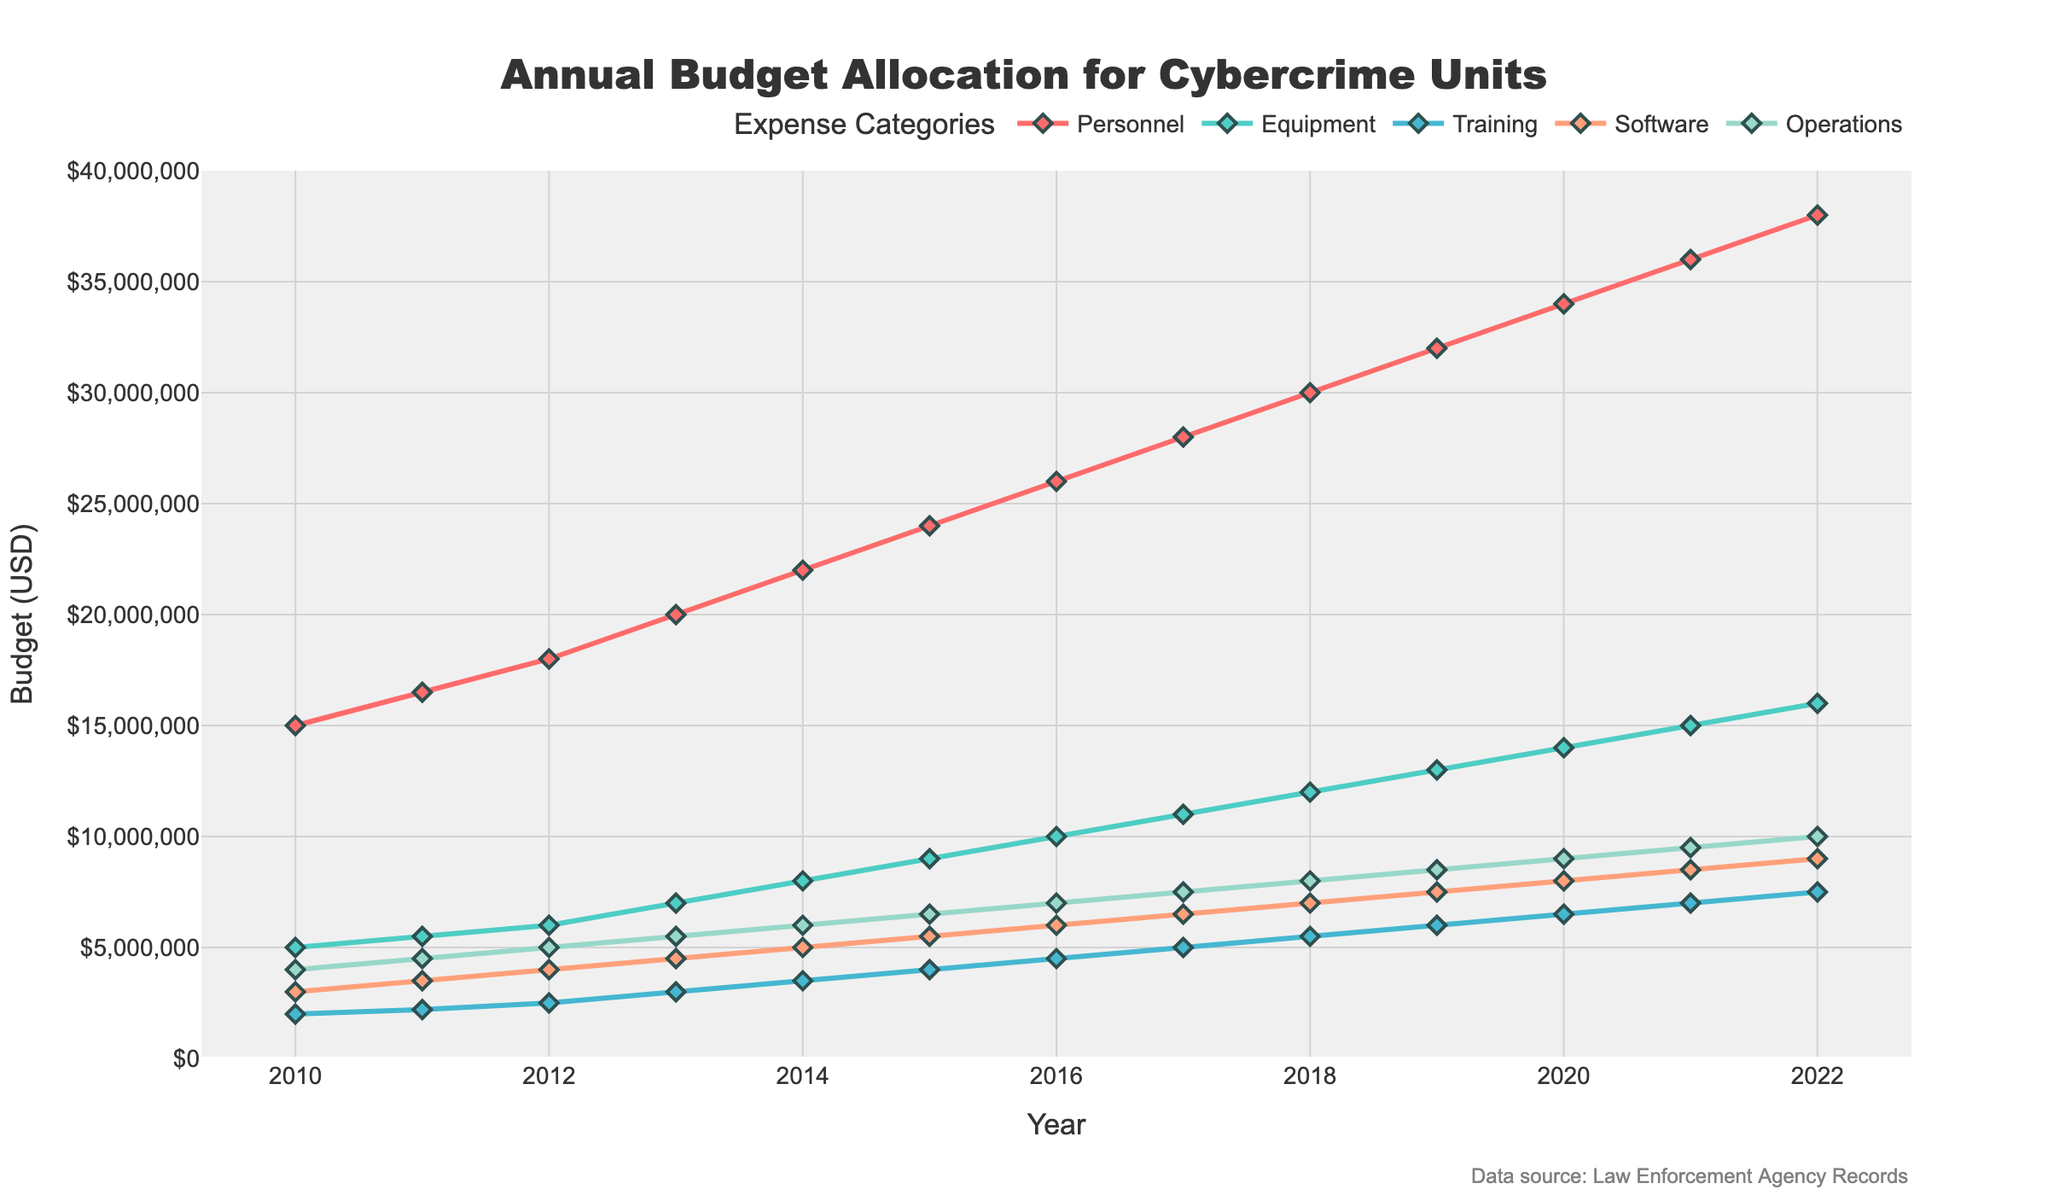What is the budget allocated to Personnel in 2014? Locate the point for the Personnel category on the line chart for the year 2014 and read the corresponding value.
Answer: 22000000 USD Between which years did the Equipment budget see the highest increase, and by how much? Compare the values of Equipment for consecutive years, and find the pair of years with the largest difference. The largest increase is from 2020 to 2021, calculated as 15000000 - 14000000.
Answer: 2020 and 2021, by 1000000 USD Which expense category had the smallest budget allocation in 2012, and what was the amount? Identify the lowest value among Personnel, Equipment, Training, Software, and Operations in 2012. The smallest value is Training with 2500000.
Answer: Training, 2500000 USD What is the total budget allocated to Operations between 2015 and 2017? Add the values for Operations in 2015, 2016, and 2017: 6500000 + 7000000 + 7500000.
Answer: 21000000 USD By how much did the Software budget increase from 2010 to 2022? Subtract the Software budget in 2010 from that in 2022: 9000000 - 3000000.
Answer: 6000000 USD Which expense category showed a consistently increasing trend from 2010 to 2022? Observe the line chart for each category and note which has a continuous upward slope throughout 2010 to 2022. All categories (Personnel, Equipment, Training, Software, Operations) show a consistently increasing trend.
Answer: All categories Did the Training budget ever exceed the Operations budget, and if so, in which year(s)? Compare the Training and Operations budgets for each year and identify if Training exceeds Operations. This occurs in: none of the years.
Answer: No year Was there any year where Equipment and Software budgets were allocated the same amount? Compare annual amounts for Equipment and Software; they are never the same.
Answer: No What was the average annual budget allocation for Software between 2010 and 2022? Add the Software budget values for each year from 2010 to 2022 and divide by the number of years (13). (3000000+3500000+4000000+4500000+5000000+5500000+6000000+6500000+7000000+7500000+8000000+8500000+9000000)/13.
Answer: Approximately 5846153.85 USD Which category had the highest budget in 2022, and what was the amount? Identify the highest value among Personnel, Equipment, Training, Software, and Operations in 2022. The highest value is Personnel with 38000000.
Answer: Personnel, 38000000 USD 